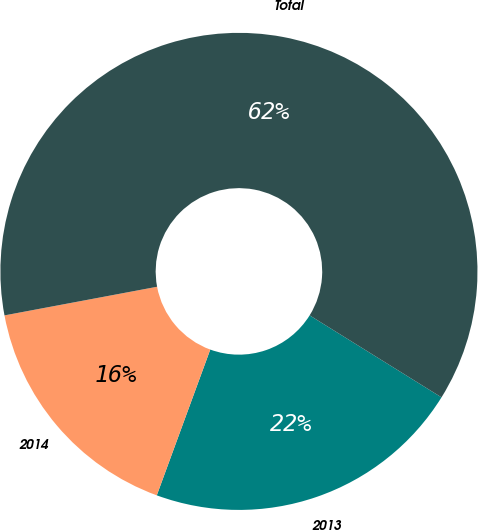Convert chart. <chart><loc_0><loc_0><loc_500><loc_500><pie_chart><fcel>2013<fcel>2014<fcel>Total<nl><fcel>21.74%<fcel>16.45%<fcel>61.8%<nl></chart> 